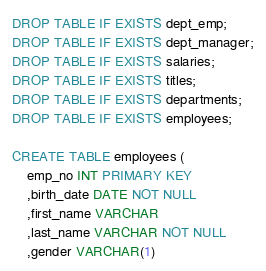<code> <loc_0><loc_0><loc_500><loc_500><_SQL_>
DROP TABLE IF EXISTS dept_emp;
DROP TABLE IF EXISTS dept_manager;
DROP TABLE IF EXISTS salaries;
DROP TABLE IF EXISTS titles;
DROP TABLE IF EXISTS departments;
DROP TABLE IF EXISTS employees;

CREATE TABLE employees (
	emp_no INT PRIMARY KEY
	,birth_date DATE NOT NULL
	,first_name VARCHAR
	,last_name VARCHAR NOT NULL
	,gender VARCHAR(1)</code> 